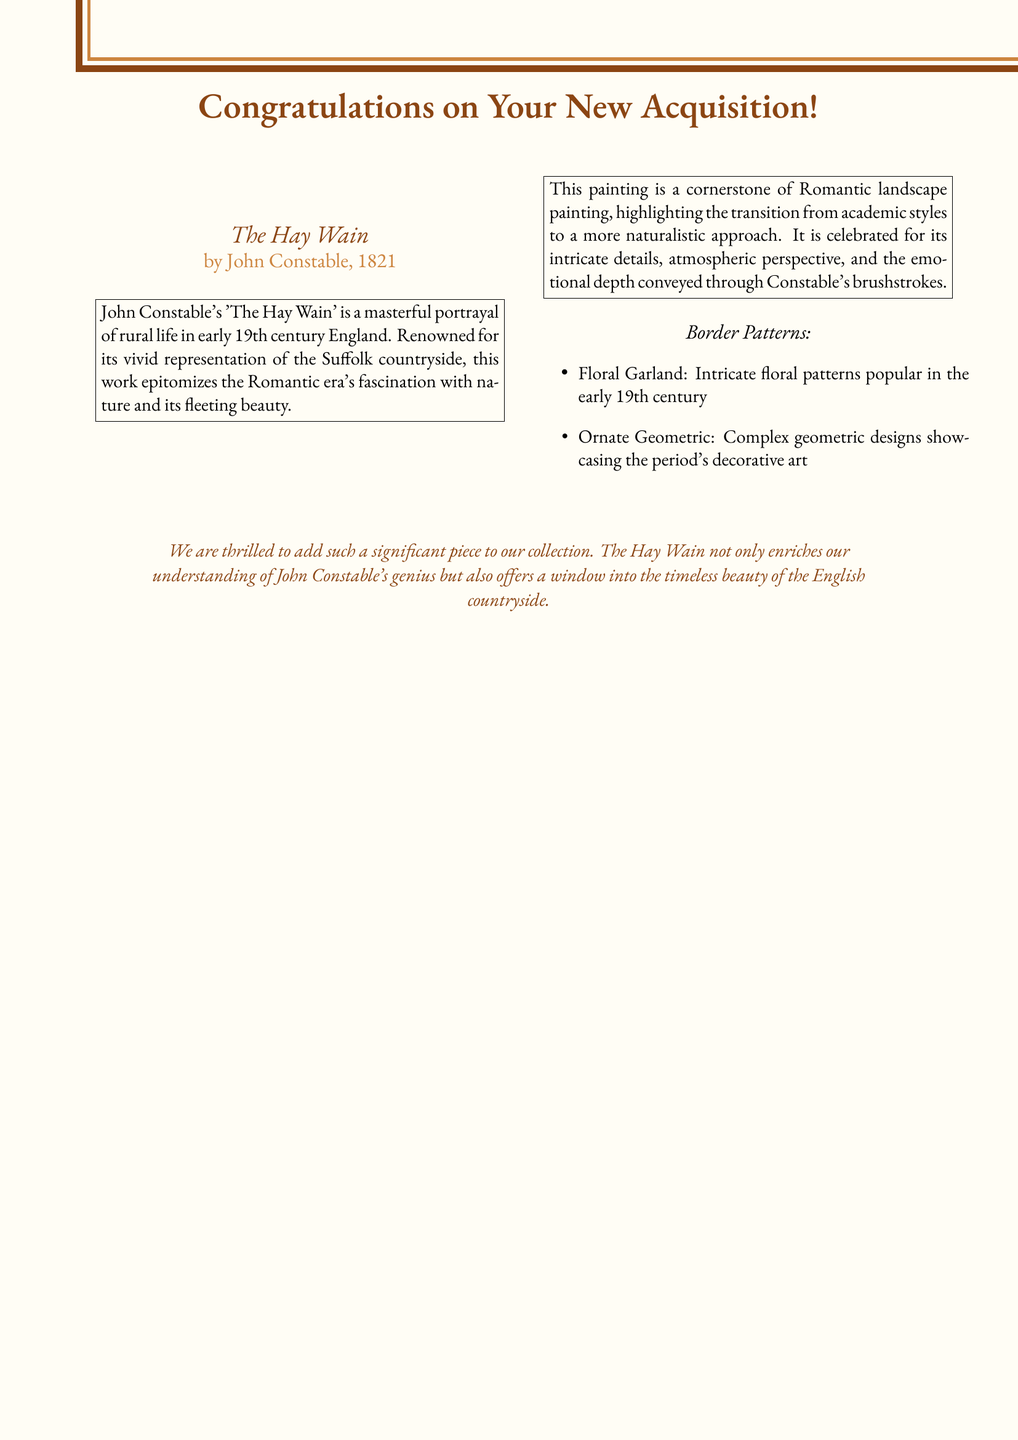What is the title of the painting? The title of the painting is mentioned prominently in the document.
Answer: The Hay Wain Who is the artist of the painting? The artist's name is indicated alongside the title in the document.
Answer: John Constable What year was the painting completed? The year of completion is provided after the artist's name in the document.
Answer: 1821 What are the two types of border patterns mentioned? The document lists two specific patterns that are reflective of the era's aesthetics.
Answer: Floral Garland, Ornate Geometric What is the primary theme of "The Hay Wain"? The document describes what the painting portrays in the context of its significance.
Answer: Rural life What does the painting highlight in terms of art style? The document discusses the painting's approach in relation to its historical context.
Answer: A more naturalistic approach How does the card express the significance of the painting in the collection? The document includes a statement about the impact of the piece in the context of the collection.
Answer: Enriches our understanding of John Constable's genius What does "The Hay Wain" signify about English countryside beauty? The document includes a phrase that captures the essence of the painting's message about nature.
Answer: Timeless beauty What is the color of the border dark in the card? The document specifies color codes for the design elements used in the card.
Answer: RGB(139,69,19) 